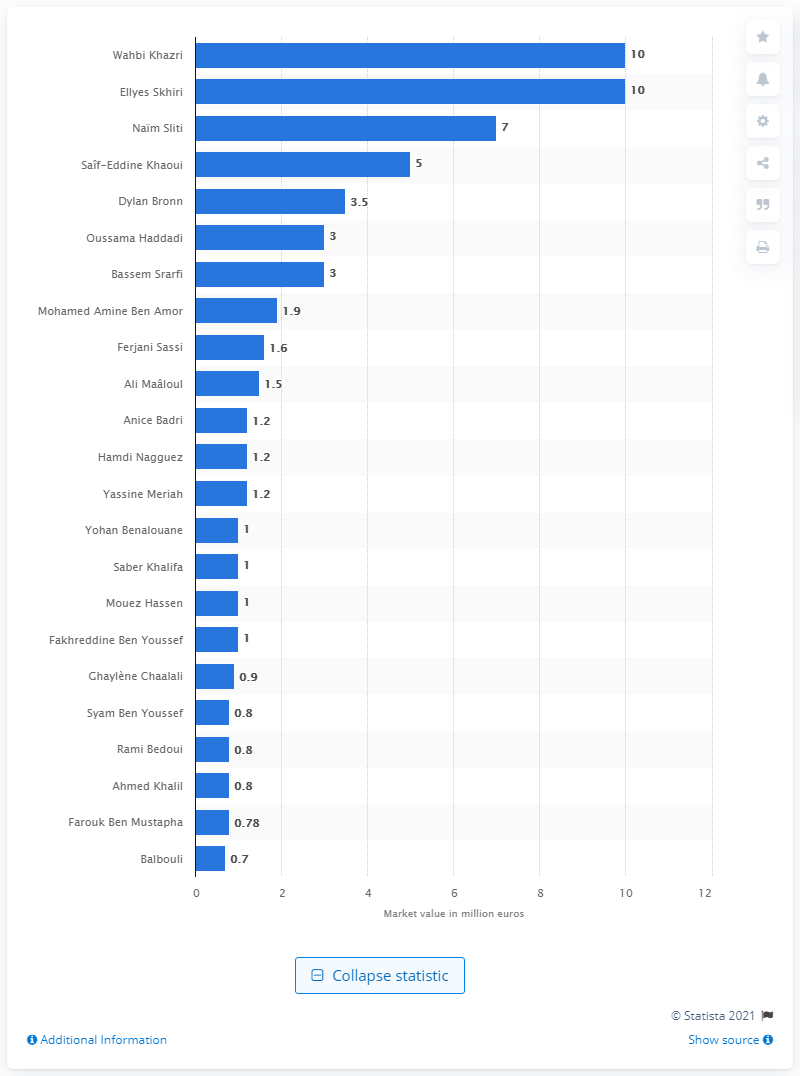Mention a couple of crucial points in this snapshot. Wahbi Khazri's market value was estimated to be 10.. The most valuable player at the 2018 FIFA World Cup was Wahbi Khazri. 